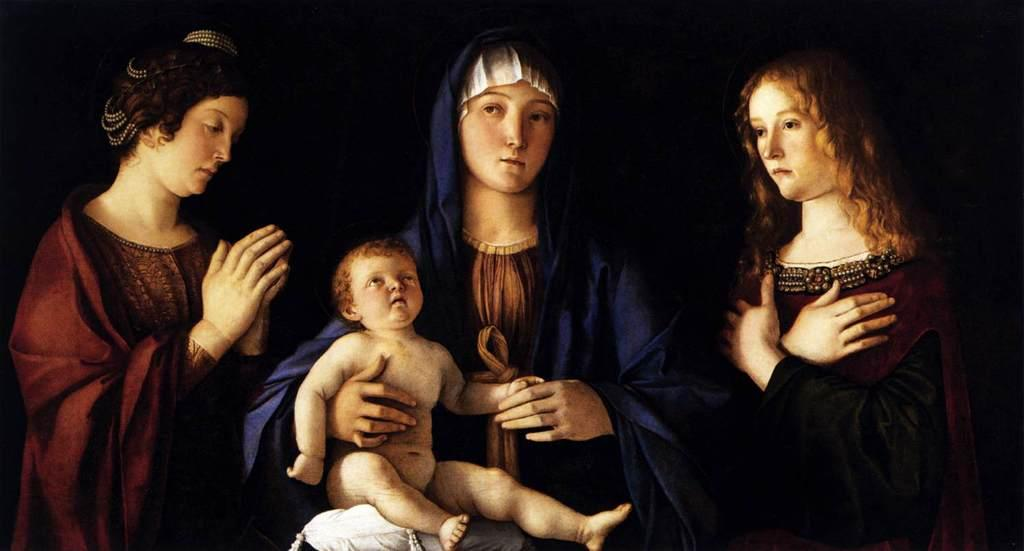How many women are in the image? There are three women depicted in the image. What other subject is present in the image besides the women? There is a baby depicted in the image. What color is the background of the image? The background of the image is black. What type of furniture or accessory is present at the bottom of the image? There is a white color cushion at the bottom of the image. What type of legal advice is the lawyer providing to the women in the image? There is no lawyer present in the image, so no legal advice can be provided. What type of quilt is covering the baby in the image? There is no quilt present in the image; the baby is not covered by any fabric. 